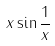<formula> <loc_0><loc_0><loc_500><loc_500>x \sin \frac { 1 } { x }</formula> 